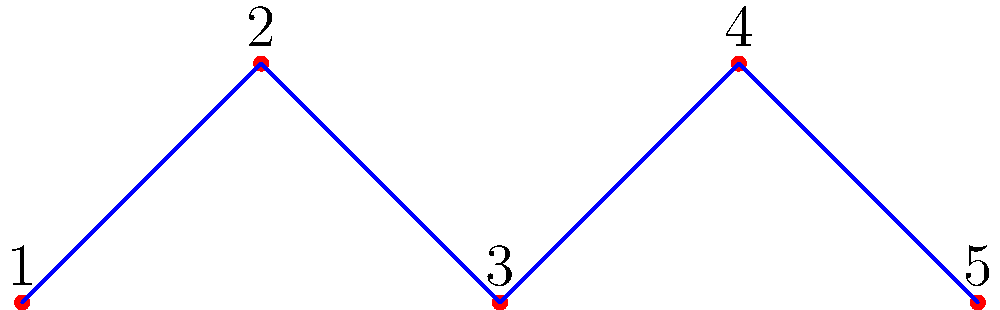In a reality TV show, five dramatic personalities (labeled 1 to 5) start as isolated individuals. The producers want to create the maximum drama by connecting these personalities. What is the minimum number of connections (represented by edges) needed to ensure that drama can spread between any two personalities, either directly or indirectly? Let's approach this step-by-step:

1) In graph theory, a fully connected network is called a connected graph.

2) The minimum number of edges needed to connect $n$ vertices in a graph is $n-1$. This creates a tree structure, which is the sparsest possible connected graph.

3) In this case, we have 5 personalities (vertices), so:
   
   Minimum number of connections = $n - 1 = 5 - 1 = 4$

4) This creates a structure called a "path graph" or a "linear graph", where each personality is connected to at most two others, but drama can still spread from any one to any other through these connections.

5) The diagram shows one possible arrangement of these 4 connections, creating a path from personality 1 to 5.

6) Adding any fewer edges would leave at least one personality isolated, while adding more would be unnecessary for achieving full connectivity (though it might create even more drama!).
Answer: 4 connections 